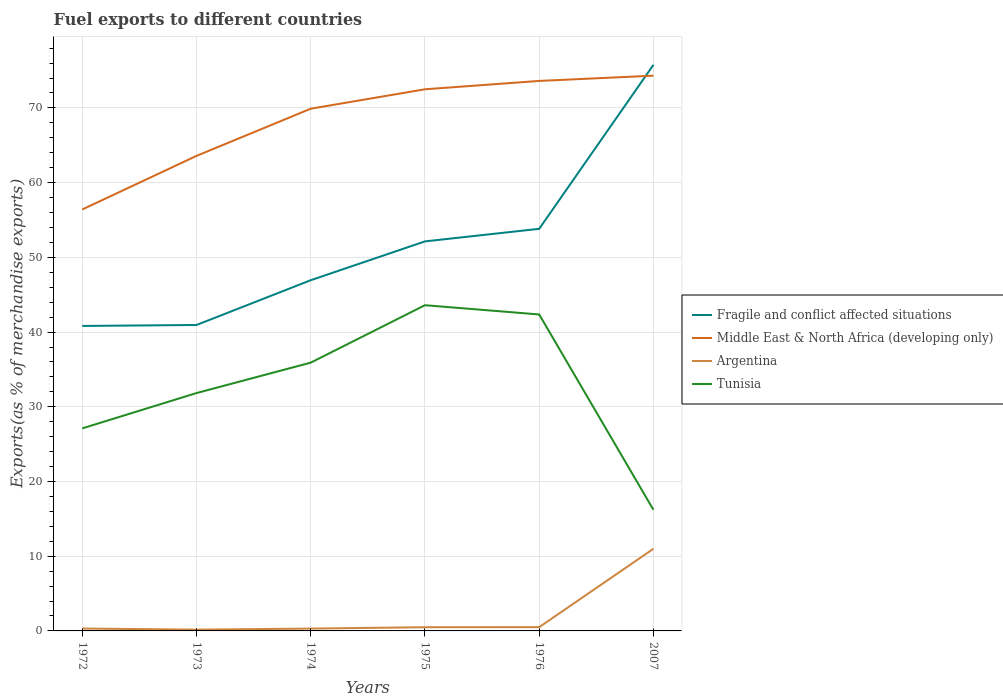How many different coloured lines are there?
Your answer should be very brief. 4. Is the number of lines equal to the number of legend labels?
Your answer should be compact. Yes. Across all years, what is the maximum percentage of exports to different countries in Argentina?
Offer a very short reply. 0.17. In which year was the percentage of exports to different countries in Middle East & North Africa (developing only) maximum?
Offer a terse response. 1972. What is the total percentage of exports to different countries in Fragile and conflict affected situations in the graph?
Provide a short and direct response. -11.19. What is the difference between the highest and the second highest percentage of exports to different countries in Fragile and conflict affected situations?
Your answer should be compact. 34.95. What is the difference between the highest and the lowest percentage of exports to different countries in Middle East & North Africa (developing only)?
Offer a terse response. 4. Is the percentage of exports to different countries in Tunisia strictly greater than the percentage of exports to different countries in Middle East & North Africa (developing only) over the years?
Provide a succinct answer. Yes. How many years are there in the graph?
Provide a succinct answer. 6. Are the values on the major ticks of Y-axis written in scientific E-notation?
Offer a terse response. No. Where does the legend appear in the graph?
Provide a short and direct response. Center right. How are the legend labels stacked?
Your answer should be very brief. Vertical. What is the title of the graph?
Make the answer very short. Fuel exports to different countries. What is the label or title of the X-axis?
Provide a succinct answer. Years. What is the label or title of the Y-axis?
Give a very brief answer. Exports(as % of merchandise exports). What is the Exports(as % of merchandise exports) in Fragile and conflict affected situations in 1972?
Make the answer very short. 40.82. What is the Exports(as % of merchandise exports) in Middle East & North Africa (developing only) in 1972?
Offer a terse response. 56.41. What is the Exports(as % of merchandise exports) of Argentina in 1972?
Provide a short and direct response. 0.32. What is the Exports(as % of merchandise exports) of Tunisia in 1972?
Your answer should be very brief. 27.11. What is the Exports(as % of merchandise exports) of Fragile and conflict affected situations in 1973?
Give a very brief answer. 40.95. What is the Exports(as % of merchandise exports) in Middle East & North Africa (developing only) in 1973?
Provide a succinct answer. 63.58. What is the Exports(as % of merchandise exports) in Argentina in 1973?
Your answer should be very brief. 0.17. What is the Exports(as % of merchandise exports) in Tunisia in 1973?
Your response must be concise. 31.84. What is the Exports(as % of merchandise exports) of Fragile and conflict affected situations in 1974?
Provide a short and direct response. 46.94. What is the Exports(as % of merchandise exports) in Middle East & North Africa (developing only) in 1974?
Keep it short and to the point. 69.9. What is the Exports(as % of merchandise exports) of Argentina in 1974?
Your answer should be very brief. 0.31. What is the Exports(as % of merchandise exports) of Tunisia in 1974?
Provide a succinct answer. 35.91. What is the Exports(as % of merchandise exports) in Fragile and conflict affected situations in 1975?
Provide a succinct answer. 52.14. What is the Exports(as % of merchandise exports) in Middle East & North Africa (developing only) in 1975?
Your answer should be compact. 72.5. What is the Exports(as % of merchandise exports) of Argentina in 1975?
Your response must be concise. 0.49. What is the Exports(as % of merchandise exports) of Tunisia in 1975?
Your answer should be compact. 43.6. What is the Exports(as % of merchandise exports) of Fragile and conflict affected situations in 1976?
Give a very brief answer. 53.82. What is the Exports(as % of merchandise exports) of Middle East & North Africa (developing only) in 1976?
Your answer should be very brief. 73.62. What is the Exports(as % of merchandise exports) in Argentina in 1976?
Ensure brevity in your answer.  0.5. What is the Exports(as % of merchandise exports) of Tunisia in 1976?
Your response must be concise. 42.36. What is the Exports(as % of merchandise exports) in Fragile and conflict affected situations in 2007?
Provide a succinct answer. 75.77. What is the Exports(as % of merchandise exports) in Middle East & North Africa (developing only) in 2007?
Offer a very short reply. 74.32. What is the Exports(as % of merchandise exports) in Argentina in 2007?
Your answer should be very brief. 10.99. What is the Exports(as % of merchandise exports) of Tunisia in 2007?
Offer a terse response. 16.21. Across all years, what is the maximum Exports(as % of merchandise exports) of Fragile and conflict affected situations?
Provide a succinct answer. 75.77. Across all years, what is the maximum Exports(as % of merchandise exports) in Middle East & North Africa (developing only)?
Offer a very short reply. 74.32. Across all years, what is the maximum Exports(as % of merchandise exports) in Argentina?
Keep it short and to the point. 10.99. Across all years, what is the maximum Exports(as % of merchandise exports) of Tunisia?
Make the answer very short. 43.6. Across all years, what is the minimum Exports(as % of merchandise exports) of Fragile and conflict affected situations?
Ensure brevity in your answer.  40.82. Across all years, what is the minimum Exports(as % of merchandise exports) of Middle East & North Africa (developing only)?
Keep it short and to the point. 56.41. Across all years, what is the minimum Exports(as % of merchandise exports) in Argentina?
Ensure brevity in your answer.  0.17. Across all years, what is the minimum Exports(as % of merchandise exports) in Tunisia?
Provide a succinct answer. 16.21. What is the total Exports(as % of merchandise exports) of Fragile and conflict affected situations in the graph?
Offer a very short reply. 310.43. What is the total Exports(as % of merchandise exports) in Middle East & North Africa (developing only) in the graph?
Give a very brief answer. 410.31. What is the total Exports(as % of merchandise exports) of Argentina in the graph?
Make the answer very short. 12.8. What is the total Exports(as % of merchandise exports) of Tunisia in the graph?
Give a very brief answer. 197.01. What is the difference between the Exports(as % of merchandise exports) of Fragile and conflict affected situations in 1972 and that in 1973?
Provide a succinct answer. -0.13. What is the difference between the Exports(as % of merchandise exports) of Middle East & North Africa (developing only) in 1972 and that in 1973?
Offer a very short reply. -7.17. What is the difference between the Exports(as % of merchandise exports) of Argentina in 1972 and that in 1973?
Your response must be concise. 0.15. What is the difference between the Exports(as % of merchandise exports) in Tunisia in 1972 and that in 1973?
Your answer should be very brief. -4.73. What is the difference between the Exports(as % of merchandise exports) in Fragile and conflict affected situations in 1972 and that in 1974?
Ensure brevity in your answer.  -6.12. What is the difference between the Exports(as % of merchandise exports) in Middle East & North Africa (developing only) in 1972 and that in 1974?
Provide a short and direct response. -13.49. What is the difference between the Exports(as % of merchandise exports) in Argentina in 1972 and that in 1974?
Offer a terse response. 0.01. What is the difference between the Exports(as % of merchandise exports) of Tunisia in 1972 and that in 1974?
Keep it short and to the point. -8.8. What is the difference between the Exports(as % of merchandise exports) of Fragile and conflict affected situations in 1972 and that in 1975?
Make the answer very short. -11.32. What is the difference between the Exports(as % of merchandise exports) of Middle East & North Africa (developing only) in 1972 and that in 1975?
Make the answer very short. -16.09. What is the difference between the Exports(as % of merchandise exports) in Argentina in 1972 and that in 1975?
Make the answer very short. -0.17. What is the difference between the Exports(as % of merchandise exports) in Tunisia in 1972 and that in 1975?
Your answer should be compact. -16.49. What is the difference between the Exports(as % of merchandise exports) in Fragile and conflict affected situations in 1972 and that in 1976?
Offer a very short reply. -13. What is the difference between the Exports(as % of merchandise exports) in Middle East & North Africa (developing only) in 1972 and that in 1976?
Your answer should be very brief. -17.21. What is the difference between the Exports(as % of merchandise exports) of Argentina in 1972 and that in 1976?
Offer a terse response. -0.18. What is the difference between the Exports(as % of merchandise exports) in Tunisia in 1972 and that in 1976?
Provide a succinct answer. -15.25. What is the difference between the Exports(as % of merchandise exports) of Fragile and conflict affected situations in 1972 and that in 2007?
Provide a short and direct response. -34.95. What is the difference between the Exports(as % of merchandise exports) of Middle East & North Africa (developing only) in 1972 and that in 2007?
Ensure brevity in your answer.  -17.91. What is the difference between the Exports(as % of merchandise exports) of Argentina in 1972 and that in 2007?
Offer a very short reply. -10.67. What is the difference between the Exports(as % of merchandise exports) in Tunisia in 1972 and that in 2007?
Provide a short and direct response. 10.9. What is the difference between the Exports(as % of merchandise exports) of Fragile and conflict affected situations in 1973 and that in 1974?
Your response must be concise. -5.99. What is the difference between the Exports(as % of merchandise exports) in Middle East & North Africa (developing only) in 1973 and that in 1974?
Offer a terse response. -6.31. What is the difference between the Exports(as % of merchandise exports) in Argentina in 1973 and that in 1974?
Offer a terse response. -0.14. What is the difference between the Exports(as % of merchandise exports) of Tunisia in 1973 and that in 1974?
Give a very brief answer. -4.07. What is the difference between the Exports(as % of merchandise exports) in Fragile and conflict affected situations in 1973 and that in 1975?
Your answer should be very brief. -11.19. What is the difference between the Exports(as % of merchandise exports) of Middle East & North Africa (developing only) in 1973 and that in 1975?
Your answer should be very brief. -8.91. What is the difference between the Exports(as % of merchandise exports) of Argentina in 1973 and that in 1975?
Make the answer very short. -0.32. What is the difference between the Exports(as % of merchandise exports) in Tunisia in 1973 and that in 1975?
Your response must be concise. -11.76. What is the difference between the Exports(as % of merchandise exports) in Fragile and conflict affected situations in 1973 and that in 1976?
Your response must be concise. -12.87. What is the difference between the Exports(as % of merchandise exports) of Middle East & North Africa (developing only) in 1973 and that in 1976?
Ensure brevity in your answer.  -10.03. What is the difference between the Exports(as % of merchandise exports) in Argentina in 1973 and that in 1976?
Ensure brevity in your answer.  -0.33. What is the difference between the Exports(as % of merchandise exports) of Tunisia in 1973 and that in 1976?
Provide a succinct answer. -10.52. What is the difference between the Exports(as % of merchandise exports) in Fragile and conflict affected situations in 1973 and that in 2007?
Your response must be concise. -34.82. What is the difference between the Exports(as % of merchandise exports) of Middle East & North Africa (developing only) in 1973 and that in 2007?
Provide a succinct answer. -10.74. What is the difference between the Exports(as % of merchandise exports) of Argentina in 1973 and that in 2007?
Make the answer very short. -10.82. What is the difference between the Exports(as % of merchandise exports) of Tunisia in 1973 and that in 2007?
Offer a very short reply. 15.63. What is the difference between the Exports(as % of merchandise exports) in Fragile and conflict affected situations in 1974 and that in 1975?
Your answer should be compact. -5.2. What is the difference between the Exports(as % of merchandise exports) of Middle East & North Africa (developing only) in 1974 and that in 1975?
Offer a very short reply. -2.6. What is the difference between the Exports(as % of merchandise exports) in Argentina in 1974 and that in 1975?
Provide a short and direct response. -0.18. What is the difference between the Exports(as % of merchandise exports) in Tunisia in 1974 and that in 1975?
Your response must be concise. -7.69. What is the difference between the Exports(as % of merchandise exports) in Fragile and conflict affected situations in 1974 and that in 1976?
Make the answer very short. -6.88. What is the difference between the Exports(as % of merchandise exports) of Middle East & North Africa (developing only) in 1974 and that in 1976?
Keep it short and to the point. -3.72. What is the difference between the Exports(as % of merchandise exports) in Argentina in 1974 and that in 1976?
Ensure brevity in your answer.  -0.19. What is the difference between the Exports(as % of merchandise exports) in Tunisia in 1974 and that in 1976?
Your response must be concise. -6.45. What is the difference between the Exports(as % of merchandise exports) in Fragile and conflict affected situations in 1974 and that in 2007?
Provide a succinct answer. -28.83. What is the difference between the Exports(as % of merchandise exports) of Middle East & North Africa (developing only) in 1974 and that in 2007?
Provide a short and direct response. -4.42. What is the difference between the Exports(as % of merchandise exports) in Argentina in 1974 and that in 2007?
Keep it short and to the point. -10.68. What is the difference between the Exports(as % of merchandise exports) in Tunisia in 1974 and that in 2007?
Keep it short and to the point. 19.7. What is the difference between the Exports(as % of merchandise exports) in Fragile and conflict affected situations in 1975 and that in 1976?
Your answer should be very brief. -1.68. What is the difference between the Exports(as % of merchandise exports) in Middle East & North Africa (developing only) in 1975 and that in 1976?
Your answer should be compact. -1.12. What is the difference between the Exports(as % of merchandise exports) in Argentina in 1975 and that in 1976?
Give a very brief answer. -0.01. What is the difference between the Exports(as % of merchandise exports) in Tunisia in 1975 and that in 1976?
Your answer should be very brief. 1.24. What is the difference between the Exports(as % of merchandise exports) of Fragile and conflict affected situations in 1975 and that in 2007?
Make the answer very short. -23.63. What is the difference between the Exports(as % of merchandise exports) of Middle East & North Africa (developing only) in 1975 and that in 2007?
Ensure brevity in your answer.  -1.82. What is the difference between the Exports(as % of merchandise exports) of Argentina in 1975 and that in 2007?
Ensure brevity in your answer.  -10.5. What is the difference between the Exports(as % of merchandise exports) in Tunisia in 1975 and that in 2007?
Keep it short and to the point. 27.39. What is the difference between the Exports(as % of merchandise exports) in Fragile and conflict affected situations in 1976 and that in 2007?
Your answer should be very brief. -21.95. What is the difference between the Exports(as % of merchandise exports) of Middle East & North Africa (developing only) in 1976 and that in 2007?
Your answer should be very brief. -0.7. What is the difference between the Exports(as % of merchandise exports) in Argentina in 1976 and that in 2007?
Ensure brevity in your answer.  -10.49. What is the difference between the Exports(as % of merchandise exports) in Tunisia in 1976 and that in 2007?
Your response must be concise. 26.15. What is the difference between the Exports(as % of merchandise exports) in Fragile and conflict affected situations in 1972 and the Exports(as % of merchandise exports) in Middle East & North Africa (developing only) in 1973?
Ensure brevity in your answer.  -22.76. What is the difference between the Exports(as % of merchandise exports) in Fragile and conflict affected situations in 1972 and the Exports(as % of merchandise exports) in Argentina in 1973?
Provide a succinct answer. 40.65. What is the difference between the Exports(as % of merchandise exports) in Fragile and conflict affected situations in 1972 and the Exports(as % of merchandise exports) in Tunisia in 1973?
Offer a terse response. 8.98. What is the difference between the Exports(as % of merchandise exports) of Middle East & North Africa (developing only) in 1972 and the Exports(as % of merchandise exports) of Argentina in 1973?
Provide a short and direct response. 56.24. What is the difference between the Exports(as % of merchandise exports) of Middle East & North Africa (developing only) in 1972 and the Exports(as % of merchandise exports) of Tunisia in 1973?
Your answer should be very brief. 24.57. What is the difference between the Exports(as % of merchandise exports) in Argentina in 1972 and the Exports(as % of merchandise exports) in Tunisia in 1973?
Your response must be concise. -31.51. What is the difference between the Exports(as % of merchandise exports) of Fragile and conflict affected situations in 1972 and the Exports(as % of merchandise exports) of Middle East & North Africa (developing only) in 1974?
Provide a succinct answer. -29.08. What is the difference between the Exports(as % of merchandise exports) in Fragile and conflict affected situations in 1972 and the Exports(as % of merchandise exports) in Argentina in 1974?
Offer a very short reply. 40.51. What is the difference between the Exports(as % of merchandise exports) in Fragile and conflict affected situations in 1972 and the Exports(as % of merchandise exports) in Tunisia in 1974?
Provide a succinct answer. 4.91. What is the difference between the Exports(as % of merchandise exports) in Middle East & North Africa (developing only) in 1972 and the Exports(as % of merchandise exports) in Argentina in 1974?
Provide a short and direct response. 56.09. What is the difference between the Exports(as % of merchandise exports) in Middle East & North Africa (developing only) in 1972 and the Exports(as % of merchandise exports) in Tunisia in 1974?
Your answer should be very brief. 20.5. What is the difference between the Exports(as % of merchandise exports) of Argentina in 1972 and the Exports(as % of merchandise exports) of Tunisia in 1974?
Provide a succinct answer. -35.59. What is the difference between the Exports(as % of merchandise exports) in Fragile and conflict affected situations in 1972 and the Exports(as % of merchandise exports) in Middle East & North Africa (developing only) in 1975?
Offer a terse response. -31.68. What is the difference between the Exports(as % of merchandise exports) of Fragile and conflict affected situations in 1972 and the Exports(as % of merchandise exports) of Argentina in 1975?
Offer a very short reply. 40.33. What is the difference between the Exports(as % of merchandise exports) in Fragile and conflict affected situations in 1972 and the Exports(as % of merchandise exports) in Tunisia in 1975?
Provide a succinct answer. -2.78. What is the difference between the Exports(as % of merchandise exports) of Middle East & North Africa (developing only) in 1972 and the Exports(as % of merchandise exports) of Argentina in 1975?
Provide a succinct answer. 55.91. What is the difference between the Exports(as % of merchandise exports) in Middle East & North Africa (developing only) in 1972 and the Exports(as % of merchandise exports) in Tunisia in 1975?
Offer a terse response. 12.81. What is the difference between the Exports(as % of merchandise exports) of Argentina in 1972 and the Exports(as % of merchandise exports) of Tunisia in 1975?
Provide a short and direct response. -43.27. What is the difference between the Exports(as % of merchandise exports) in Fragile and conflict affected situations in 1972 and the Exports(as % of merchandise exports) in Middle East & North Africa (developing only) in 1976?
Offer a terse response. -32.79. What is the difference between the Exports(as % of merchandise exports) in Fragile and conflict affected situations in 1972 and the Exports(as % of merchandise exports) in Argentina in 1976?
Provide a short and direct response. 40.32. What is the difference between the Exports(as % of merchandise exports) in Fragile and conflict affected situations in 1972 and the Exports(as % of merchandise exports) in Tunisia in 1976?
Offer a very short reply. -1.53. What is the difference between the Exports(as % of merchandise exports) of Middle East & North Africa (developing only) in 1972 and the Exports(as % of merchandise exports) of Argentina in 1976?
Your response must be concise. 55.91. What is the difference between the Exports(as % of merchandise exports) in Middle East & North Africa (developing only) in 1972 and the Exports(as % of merchandise exports) in Tunisia in 1976?
Offer a terse response. 14.05. What is the difference between the Exports(as % of merchandise exports) in Argentina in 1972 and the Exports(as % of merchandise exports) in Tunisia in 1976?
Offer a very short reply. -42.03. What is the difference between the Exports(as % of merchandise exports) in Fragile and conflict affected situations in 1972 and the Exports(as % of merchandise exports) in Middle East & North Africa (developing only) in 2007?
Make the answer very short. -33.5. What is the difference between the Exports(as % of merchandise exports) of Fragile and conflict affected situations in 1972 and the Exports(as % of merchandise exports) of Argentina in 2007?
Make the answer very short. 29.83. What is the difference between the Exports(as % of merchandise exports) in Fragile and conflict affected situations in 1972 and the Exports(as % of merchandise exports) in Tunisia in 2007?
Offer a very short reply. 24.61. What is the difference between the Exports(as % of merchandise exports) of Middle East & North Africa (developing only) in 1972 and the Exports(as % of merchandise exports) of Argentina in 2007?
Ensure brevity in your answer.  45.41. What is the difference between the Exports(as % of merchandise exports) in Middle East & North Africa (developing only) in 1972 and the Exports(as % of merchandise exports) in Tunisia in 2007?
Ensure brevity in your answer.  40.2. What is the difference between the Exports(as % of merchandise exports) in Argentina in 1972 and the Exports(as % of merchandise exports) in Tunisia in 2007?
Give a very brief answer. -15.89. What is the difference between the Exports(as % of merchandise exports) of Fragile and conflict affected situations in 1973 and the Exports(as % of merchandise exports) of Middle East & North Africa (developing only) in 1974?
Keep it short and to the point. -28.95. What is the difference between the Exports(as % of merchandise exports) of Fragile and conflict affected situations in 1973 and the Exports(as % of merchandise exports) of Argentina in 1974?
Make the answer very short. 40.63. What is the difference between the Exports(as % of merchandise exports) in Fragile and conflict affected situations in 1973 and the Exports(as % of merchandise exports) in Tunisia in 1974?
Ensure brevity in your answer.  5.04. What is the difference between the Exports(as % of merchandise exports) of Middle East & North Africa (developing only) in 1973 and the Exports(as % of merchandise exports) of Argentina in 1974?
Ensure brevity in your answer.  63.27. What is the difference between the Exports(as % of merchandise exports) of Middle East & North Africa (developing only) in 1973 and the Exports(as % of merchandise exports) of Tunisia in 1974?
Ensure brevity in your answer.  27.67. What is the difference between the Exports(as % of merchandise exports) in Argentina in 1973 and the Exports(as % of merchandise exports) in Tunisia in 1974?
Make the answer very short. -35.74. What is the difference between the Exports(as % of merchandise exports) in Fragile and conflict affected situations in 1973 and the Exports(as % of merchandise exports) in Middle East & North Africa (developing only) in 1975?
Offer a very short reply. -31.55. What is the difference between the Exports(as % of merchandise exports) of Fragile and conflict affected situations in 1973 and the Exports(as % of merchandise exports) of Argentina in 1975?
Offer a very short reply. 40.45. What is the difference between the Exports(as % of merchandise exports) in Fragile and conflict affected situations in 1973 and the Exports(as % of merchandise exports) in Tunisia in 1975?
Provide a short and direct response. -2.65. What is the difference between the Exports(as % of merchandise exports) of Middle East & North Africa (developing only) in 1973 and the Exports(as % of merchandise exports) of Argentina in 1975?
Your answer should be compact. 63.09. What is the difference between the Exports(as % of merchandise exports) in Middle East & North Africa (developing only) in 1973 and the Exports(as % of merchandise exports) in Tunisia in 1975?
Offer a terse response. 19.98. What is the difference between the Exports(as % of merchandise exports) of Argentina in 1973 and the Exports(as % of merchandise exports) of Tunisia in 1975?
Your answer should be compact. -43.42. What is the difference between the Exports(as % of merchandise exports) of Fragile and conflict affected situations in 1973 and the Exports(as % of merchandise exports) of Middle East & North Africa (developing only) in 1976?
Give a very brief answer. -32.67. What is the difference between the Exports(as % of merchandise exports) in Fragile and conflict affected situations in 1973 and the Exports(as % of merchandise exports) in Argentina in 1976?
Give a very brief answer. 40.44. What is the difference between the Exports(as % of merchandise exports) in Fragile and conflict affected situations in 1973 and the Exports(as % of merchandise exports) in Tunisia in 1976?
Offer a very short reply. -1.41. What is the difference between the Exports(as % of merchandise exports) in Middle East & North Africa (developing only) in 1973 and the Exports(as % of merchandise exports) in Argentina in 1976?
Make the answer very short. 63.08. What is the difference between the Exports(as % of merchandise exports) of Middle East & North Africa (developing only) in 1973 and the Exports(as % of merchandise exports) of Tunisia in 1976?
Your answer should be compact. 21.23. What is the difference between the Exports(as % of merchandise exports) of Argentina in 1973 and the Exports(as % of merchandise exports) of Tunisia in 1976?
Your response must be concise. -42.18. What is the difference between the Exports(as % of merchandise exports) in Fragile and conflict affected situations in 1973 and the Exports(as % of merchandise exports) in Middle East & North Africa (developing only) in 2007?
Give a very brief answer. -33.37. What is the difference between the Exports(as % of merchandise exports) in Fragile and conflict affected situations in 1973 and the Exports(as % of merchandise exports) in Argentina in 2007?
Your response must be concise. 29.95. What is the difference between the Exports(as % of merchandise exports) in Fragile and conflict affected situations in 1973 and the Exports(as % of merchandise exports) in Tunisia in 2007?
Your response must be concise. 24.74. What is the difference between the Exports(as % of merchandise exports) of Middle East & North Africa (developing only) in 1973 and the Exports(as % of merchandise exports) of Argentina in 2007?
Make the answer very short. 52.59. What is the difference between the Exports(as % of merchandise exports) in Middle East & North Africa (developing only) in 1973 and the Exports(as % of merchandise exports) in Tunisia in 2007?
Provide a succinct answer. 47.37. What is the difference between the Exports(as % of merchandise exports) of Argentina in 1973 and the Exports(as % of merchandise exports) of Tunisia in 2007?
Offer a terse response. -16.04. What is the difference between the Exports(as % of merchandise exports) in Fragile and conflict affected situations in 1974 and the Exports(as % of merchandise exports) in Middle East & North Africa (developing only) in 1975?
Offer a terse response. -25.56. What is the difference between the Exports(as % of merchandise exports) in Fragile and conflict affected situations in 1974 and the Exports(as % of merchandise exports) in Argentina in 1975?
Give a very brief answer. 46.45. What is the difference between the Exports(as % of merchandise exports) of Fragile and conflict affected situations in 1974 and the Exports(as % of merchandise exports) of Tunisia in 1975?
Your response must be concise. 3.34. What is the difference between the Exports(as % of merchandise exports) in Middle East & North Africa (developing only) in 1974 and the Exports(as % of merchandise exports) in Argentina in 1975?
Your response must be concise. 69.4. What is the difference between the Exports(as % of merchandise exports) of Middle East & North Africa (developing only) in 1974 and the Exports(as % of merchandise exports) of Tunisia in 1975?
Provide a short and direct response. 26.3. What is the difference between the Exports(as % of merchandise exports) in Argentina in 1974 and the Exports(as % of merchandise exports) in Tunisia in 1975?
Provide a succinct answer. -43.28. What is the difference between the Exports(as % of merchandise exports) of Fragile and conflict affected situations in 1974 and the Exports(as % of merchandise exports) of Middle East & North Africa (developing only) in 1976?
Provide a succinct answer. -26.68. What is the difference between the Exports(as % of merchandise exports) of Fragile and conflict affected situations in 1974 and the Exports(as % of merchandise exports) of Argentina in 1976?
Give a very brief answer. 46.44. What is the difference between the Exports(as % of merchandise exports) of Fragile and conflict affected situations in 1974 and the Exports(as % of merchandise exports) of Tunisia in 1976?
Keep it short and to the point. 4.58. What is the difference between the Exports(as % of merchandise exports) of Middle East & North Africa (developing only) in 1974 and the Exports(as % of merchandise exports) of Argentina in 1976?
Provide a short and direct response. 69.39. What is the difference between the Exports(as % of merchandise exports) in Middle East & North Africa (developing only) in 1974 and the Exports(as % of merchandise exports) in Tunisia in 1976?
Ensure brevity in your answer.  27.54. What is the difference between the Exports(as % of merchandise exports) of Argentina in 1974 and the Exports(as % of merchandise exports) of Tunisia in 1976?
Provide a short and direct response. -42.04. What is the difference between the Exports(as % of merchandise exports) in Fragile and conflict affected situations in 1974 and the Exports(as % of merchandise exports) in Middle East & North Africa (developing only) in 2007?
Provide a short and direct response. -27.38. What is the difference between the Exports(as % of merchandise exports) in Fragile and conflict affected situations in 1974 and the Exports(as % of merchandise exports) in Argentina in 2007?
Offer a terse response. 35.95. What is the difference between the Exports(as % of merchandise exports) of Fragile and conflict affected situations in 1974 and the Exports(as % of merchandise exports) of Tunisia in 2007?
Provide a succinct answer. 30.73. What is the difference between the Exports(as % of merchandise exports) of Middle East & North Africa (developing only) in 1974 and the Exports(as % of merchandise exports) of Argentina in 2007?
Give a very brief answer. 58.9. What is the difference between the Exports(as % of merchandise exports) of Middle East & North Africa (developing only) in 1974 and the Exports(as % of merchandise exports) of Tunisia in 2007?
Your response must be concise. 53.69. What is the difference between the Exports(as % of merchandise exports) of Argentina in 1974 and the Exports(as % of merchandise exports) of Tunisia in 2007?
Offer a terse response. -15.89. What is the difference between the Exports(as % of merchandise exports) in Fragile and conflict affected situations in 1975 and the Exports(as % of merchandise exports) in Middle East & North Africa (developing only) in 1976?
Ensure brevity in your answer.  -21.48. What is the difference between the Exports(as % of merchandise exports) in Fragile and conflict affected situations in 1975 and the Exports(as % of merchandise exports) in Argentina in 1976?
Make the answer very short. 51.63. What is the difference between the Exports(as % of merchandise exports) in Fragile and conflict affected situations in 1975 and the Exports(as % of merchandise exports) in Tunisia in 1976?
Your response must be concise. 9.78. What is the difference between the Exports(as % of merchandise exports) of Middle East & North Africa (developing only) in 1975 and the Exports(as % of merchandise exports) of Argentina in 1976?
Your response must be concise. 71.99. What is the difference between the Exports(as % of merchandise exports) in Middle East & North Africa (developing only) in 1975 and the Exports(as % of merchandise exports) in Tunisia in 1976?
Make the answer very short. 30.14. What is the difference between the Exports(as % of merchandise exports) of Argentina in 1975 and the Exports(as % of merchandise exports) of Tunisia in 1976?
Provide a succinct answer. -41.86. What is the difference between the Exports(as % of merchandise exports) in Fragile and conflict affected situations in 1975 and the Exports(as % of merchandise exports) in Middle East & North Africa (developing only) in 2007?
Your answer should be compact. -22.18. What is the difference between the Exports(as % of merchandise exports) of Fragile and conflict affected situations in 1975 and the Exports(as % of merchandise exports) of Argentina in 2007?
Your answer should be very brief. 41.14. What is the difference between the Exports(as % of merchandise exports) in Fragile and conflict affected situations in 1975 and the Exports(as % of merchandise exports) in Tunisia in 2007?
Your response must be concise. 35.93. What is the difference between the Exports(as % of merchandise exports) of Middle East & North Africa (developing only) in 1975 and the Exports(as % of merchandise exports) of Argentina in 2007?
Your answer should be very brief. 61.5. What is the difference between the Exports(as % of merchandise exports) of Middle East & North Africa (developing only) in 1975 and the Exports(as % of merchandise exports) of Tunisia in 2007?
Provide a succinct answer. 56.29. What is the difference between the Exports(as % of merchandise exports) in Argentina in 1975 and the Exports(as % of merchandise exports) in Tunisia in 2007?
Offer a very short reply. -15.71. What is the difference between the Exports(as % of merchandise exports) of Fragile and conflict affected situations in 1976 and the Exports(as % of merchandise exports) of Middle East & North Africa (developing only) in 2007?
Keep it short and to the point. -20.5. What is the difference between the Exports(as % of merchandise exports) of Fragile and conflict affected situations in 1976 and the Exports(as % of merchandise exports) of Argentina in 2007?
Provide a short and direct response. 42.83. What is the difference between the Exports(as % of merchandise exports) of Fragile and conflict affected situations in 1976 and the Exports(as % of merchandise exports) of Tunisia in 2007?
Ensure brevity in your answer.  37.61. What is the difference between the Exports(as % of merchandise exports) in Middle East & North Africa (developing only) in 1976 and the Exports(as % of merchandise exports) in Argentina in 2007?
Ensure brevity in your answer.  62.62. What is the difference between the Exports(as % of merchandise exports) in Middle East & North Africa (developing only) in 1976 and the Exports(as % of merchandise exports) in Tunisia in 2007?
Ensure brevity in your answer.  57.41. What is the difference between the Exports(as % of merchandise exports) of Argentina in 1976 and the Exports(as % of merchandise exports) of Tunisia in 2007?
Your answer should be compact. -15.7. What is the average Exports(as % of merchandise exports) in Fragile and conflict affected situations per year?
Provide a succinct answer. 51.74. What is the average Exports(as % of merchandise exports) in Middle East & North Africa (developing only) per year?
Provide a short and direct response. 68.39. What is the average Exports(as % of merchandise exports) of Argentina per year?
Offer a very short reply. 2.13. What is the average Exports(as % of merchandise exports) in Tunisia per year?
Offer a terse response. 32.84. In the year 1972, what is the difference between the Exports(as % of merchandise exports) in Fragile and conflict affected situations and Exports(as % of merchandise exports) in Middle East & North Africa (developing only)?
Keep it short and to the point. -15.59. In the year 1972, what is the difference between the Exports(as % of merchandise exports) in Fragile and conflict affected situations and Exports(as % of merchandise exports) in Argentina?
Make the answer very short. 40.5. In the year 1972, what is the difference between the Exports(as % of merchandise exports) in Fragile and conflict affected situations and Exports(as % of merchandise exports) in Tunisia?
Provide a succinct answer. 13.71. In the year 1972, what is the difference between the Exports(as % of merchandise exports) in Middle East & North Africa (developing only) and Exports(as % of merchandise exports) in Argentina?
Provide a succinct answer. 56.09. In the year 1972, what is the difference between the Exports(as % of merchandise exports) in Middle East & North Africa (developing only) and Exports(as % of merchandise exports) in Tunisia?
Your answer should be compact. 29.3. In the year 1972, what is the difference between the Exports(as % of merchandise exports) of Argentina and Exports(as % of merchandise exports) of Tunisia?
Offer a very short reply. -26.79. In the year 1973, what is the difference between the Exports(as % of merchandise exports) of Fragile and conflict affected situations and Exports(as % of merchandise exports) of Middle East & North Africa (developing only)?
Your answer should be compact. -22.63. In the year 1973, what is the difference between the Exports(as % of merchandise exports) in Fragile and conflict affected situations and Exports(as % of merchandise exports) in Argentina?
Your response must be concise. 40.78. In the year 1973, what is the difference between the Exports(as % of merchandise exports) of Fragile and conflict affected situations and Exports(as % of merchandise exports) of Tunisia?
Provide a short and direct response. 9.11. In the year 1973, what is the difference between the Exports(as % of merchandise exports) of Middle East & North Africa (developing only) and Exports(as % of merchandise exports) of Argentina?
Your answer should be compact. 63.41. In the year 1973, what is the difference between the Exports(as % of merchandise exports) in Middle East & North Africa (developing only) and Exports(as % of merchandise exports) in Tunisia?
Your answer should be compact. 31.75. In the year 1973, what is the difference between the Exports(as % of merchandise exports) of Argentina and Exports(as % of merchandise exports) of Tunisia?
Ensure brevity in your answer.  -31.66. In the year 1974, what is the difference between the Exports(as % of merchandise exports) in Fragile and conflict affected situations and Exports(as % of merchandise exports) in Middle East & North Africa (developing only)?
Your response must be concise. -22.96. In the year 1974, what is the difference between the Exports(as % of merchandise exports) of Fragile and conflict affected situations and Exports(as % of merchandise exports) of Argentina?
Ensure brevity in your answer.  46.63. In the year 1974, what is the difference between the Exports(as % of merchandise exports) in Fragile and conflict affected situations and Exports(as % of merchandise exports) in Tunisia?
Offer a very short reply. 11.03. In the year 1974, what is the difference between the Exports(as % of merchandise exports) of Middle East & North Africa (developing only) and Exports(as % of merchandise exports) of Argentina?
Give a very brief answer. 69.58. In the year 1974, what is the difference between the Exports(as % of merchandise exports) in Middle East & North Africa (developing only) and Exports(as % of merchandise exports) in Tunisia?
Give a very brief answer. 33.99. In the year 1974, what is the difference between the Exports(as % of merchandise exports) of Argentina and Exports(as % of merchandise exports) of Tunisia?
Your answer should be compact. -35.59. In the year 1975, what is the difference between the Exports(as % of merchandise exports) of Fragile and conflict affected situations and Exports(as % of merchandise exports) of Middle East & North Africa (developing only)?
Your answer should be compact. -20.36. In the year 1975, what is the difference between the Exports(as % of merchandise exports) in Fragile and conflict affected situations and Exports(as % of merchandise exports) in Argentina?
Offer a very short reply. 51.64. In the year 1975, what is the difference between the Exports(as % of merchandise exports) in Fragile and conflict affected situations and Exports(as % of merchandise exports) in Tunisia?
Offer a very short reply. 8.54. In the year 1975, what is the difference between the Exports(as % of merchandise exports) of Middle East & North Africa (developing only) and Exports(as % of merchandise exports) of Argentina?
Your answer should be compact. 72. In the year 1975, what is the difference between the Exports(as % of merchandise exports) in Middle East & North Africa (developing only) and Exports(as % of merchandise exports) in Tunisia?
Your answer should be very brief. 28.9. In the year 1975, what is the difference between the Exports(as % of merchandise exports) of Argentina and Exports(as % of merchandise exports) of Tunisia?
Give a very brief answer. -43.1. In the year 1976, what is the difference between the Exports(as % of merchandise exports) of Fragile and conflict affected situations and Exports(as % of merchandise exports) of Middle East & North Africa (developing only)?
Your answer should be very brief. -19.8. In the year 1976, what is the difference between the Exports(as % of merchandise exports) in Fragile and conflict affected situations and Exports(as % of merchandise exports) in Argentina?
Keep it short and to the point. 53.32. In the year 1976, what is the difference between the Exports(as % of merchandise exports) of Fragile and conflict affected situations and Exports(as % of merchandise exports) of Tunisia?
Provide a short and direct response. 11.46. In the year 1976, what is the difference between the Exports(as % of merchandise exports) of Middle East & North Africa (developing only) and Exports(as % of merchandise exports) of Argentina?
Your answer should be compact. 73.11. In the year 1976, what is the difference between the Exports(as % of merchandise exports) of Middle East & North Africa (developing only) and Exports(as % of merchandise exports) of Tunisia?
Your response must be concise. 31.26. In the year 1976, what is the difference between the Exports(as % of merchandise exports) of Argentina and Exports(as % of merchandise exports) of Tunisia?
Provide a succinct answer. -41.85. In the year 2007, what is the difference between the Exports(as % of merchandise exports) of Fragile and conflict affected situations and Exports(as % of merchandise exports) of Middle East & North Africa (developing only)?
Keep it short and to the point. 1.45. In the year 2007, what is the difference between the Exports(as % of merchandise exports) in Fragile and conflict affected situations and Exports(as % of merchandise exports) in Argentina?
Offer a terse response. 64.78. In the year 2007, what is the difference between the Exports(as % of merchandise exports) of Fragile and conflict affected situations and Exports(as % of merchandise exports) of Tunisia?
Provide a short and direct response. 59.56. In the year 2007, what is the difference between the Exports(as % of merchandise exports) in Middle East & North Africa (developing only) and Exports(as % of merchandise exports) in Argentina?
Your response must be concise. 63.32. In the year 2007, what is the difference between the Exports(as % of merchandise exports) in Middle East & North Africa (developing only) and Exports(as % of merchandise exports) in Tunisia?
Ensure brevity in your answer.  58.11. In the year 2007, what is the difference between the Exports(as % of merchandise exports) in Argentina and Exports(as % of merchandise exports) in Tunisia?
Make the answer very short. -5.21. What is the ratio of the Exports(as % of merchandise exports) of Middle East & North Africa (developing only) in 1972 to that in 1973?
Give a very brief answer. 0.89. What is the ratio of the Exports(as % of merchandise exports) of Argentina in 1972 to that in 1973?
Offer a terse response. 1.88. What is the ratio of the Exports(as % of merchandise exports) in Tunisia in 1972 to that in 1973?
Provide a succinct answer. 0.85. What is the ratio of the Exports(as % of merchandise exports) in Fragile and conflict affected situations in 1972 to that in 1974?
Provide a succinct answer. 0.87. What is the ratio of the Exports(as % of merchandise exports) of Middle East & North Africa (developing only) in 1972 to that in 1974?
Your answer should be compact. 0.81. What is the ratio of the Exports(as % of merchandise exports) in Argentina in 1972 to that in 1974?
Offer a terse response. 1.03. What is the ratio of the Exports(as % of merchandise exports) in Tunisia in 1972 to that in 1974?
Offer a very short reply. 0.76. What is the ratio of the Exports(as % of merchandise exports) of Fragile and conflict affected situations in 1972 to that in 1975?
Offer a very short reply. 0.78. What is the ratio of the Exports(as % of merchandise exports) of Middle East & North Africa (developing only) in 1972 to that in 1975?
Your response must be concise. 0.78. What is the ratio of the Exports(as % of merchandise exports) of Argentina in 1972 to that in 1975?
Offer a very short reply. 0.65. What is the ratio of the Exports(as % of merchandise exports) in Tunisia in 1972 to that in 1975?
Keep it short and to the point. 0.62. What is the ratio of the Exports(as % of merchandise exports) of Fragile and conflict affected situations in 1972 to that in 1976?
Your answer should be very brief. 0.76. What is the ratio of the Exports(as % of merchandise exports) in Middle East & North Africa (developing only) in 1972 to that in 1976?
Your answer should be very brief. 0.77. What is the ratio of the Exports(as % of merchandise exports) in Argentina in 1972 to that in 1976?
Offer a terse response. 0.64. What is the ratio of the Exports(as % of merchandise exports) of Tunisia in 1972 to that in 1976?
Keep it short and to the point. 0.64. What is the ratio of the Exports(as % of merchandise exports) in Fragile and conflict affected situations in 1972 to that in 2007?
Your response must be concise. 0.54. What is the ratio of the Exports(as % of merchandise exports) of Middle East & North Africa (developing only) in 1972 to that in 2007?
Your answer should be compact. 0.76. What is the ratio of the Exports(as % of merchandise exports) in Argentina in 1972 to that in 2007?
Your response must be concise. 0.03. What is the ratio of the Exports(as % of merchandise exports) of Tunisia in 1972 to that in 2007?
Offer a very short reply. 1.67. What is the ratio of the Exports(as % of merchandise exports) in Fragile and conflict affected situations in 1973 to that in 1974?
Offer a terse response. 0.87. What is the ratio of the Exports(as % of merchandise exports) in Middle East & North Africa (developing only) in 1973 to that in 1974?
Make the answer very short. 0.91. What is the ratio of the Exports(as % of merchandise exports) in Argentina in 1973 to that in 1974?
Provide a short and direct response. 0.55. What is the ratio of the Exports(as % of merchandise exports) in Tunisia in 1973 to that in 1974?
Make the answer very short. 0.89. What is the ratio of the Exports(as % of merchandise exports) of Fragile and conflict affected situations in 1973 to that in 1975?
Make the answer very short. 0.79. What is the ratio of the Exports(as % of merchandise exports) of Middle East & North Africa (developing only) in 1973 to that in 1975?
Make the answer very short. 0.88. What is the ratio of the Exports(as % of merchandise exports) of Argentina in 1973 to that in 1975?
Offer a terse response. 0.35. What is the ratio of the Exports(as % of merchandise exports) of Tunisia in 1973 to that in 1975?
Give a very brief answer. 0.73. What is the ratio of the Exports(as % of merchandise exports) in Fragile and conflict affected situations in 1973 to that in 1976?
Your answer should be very brief. 0.76. What is the ratio of the Exports(as % of merchandise exports) in Middle East & North Africa (developing only) in 1973 to that in 1976?
Ensure brevity in your answer.  0.86. What is the ratio of the Exports(as % of merchandise exports) of Argentina in 1973 to that in 1976?
Your answer should be compact. 0.34. What is the ratio of the Exports(as % of merchandise exports) in Tunisia in 1973 to that in 1976?
Provide a short and direct response. 0.75. What is the ratio of the Exports(as % of merchandise exports) in Fragile and conflict affected situations in 1973 to that in 2007?
Give a very brief answer. 0.54. What is the ratio of the Exports(as % of merchandise exports) in Middle East & North Africa (developing only) in 1973 to that in 2007?
Your answer should be very brief. 0.86. What is the ratio of the Exports(as % of merchandise exports) in Argentina in 1973 to that in 2007?
Offer a very short reply. 0.02. What is the ratio of the Exports(as % of merchandise exports) of Tunisia in 1973 to that in 2007?
Your answer should be compact. 1.96. What is the ratio of the Exports(as % of merchandise exports) of Fragile and conflict affected situations in 1974 to that in 1975?
Make the answer very short. 0.9. What is the ratio of the Exports(as % of merchandise exports) in Middle East & North Africa (developing only) in 1974 to that in 1975?
Ensure brevity in your answer.  0.96. What is the ratio of the Exports(as % of merchandise exports) of Argentina in 1974 to that in 1975?
Give a very brief answer. 0.63. What is the ratio of the Exports(as % of merchandise exports) in Tunisia in 1974 to that in 1975?
Your answer should be very brief. 0.82. What is the ratio of the Exports(as % of merchandise exports) in Fragile and conflict affected situations in 1974 to that in 1976?
Provide a succinct answer. 0.87. What is the ratio of the Exports(as % of merchandise exports) of Middle East & North Africa (developing only) in 1974 to that in 1976?
Your response must be concise. 0.95. What is the ratio of the Exports(as % of merchandise exports) of Argentina in 1974 to that in 1976?
Offer a terse response. 0.62. What is the ratio of the Exports(as % of merchandise exports) of Tunisia in 1974 to that in 1976?
Provide a succinct answer. 0.85. What is the ratio of the Exports(as % of merchandise exports) in Fragile and conflict affected situations in 1974 to that in 2007?
Provide a succinct answer. 0.62. What is the ratio of the Exports(as % of merchandise exports) of Middle East & North Africa (developing only) in 1974 to that in 2007?
Ensure brevity in your answer.  0.94. What is the ratio of the Exports(as % of merchandise exports) in Argentina in 1974 to that in 2007?
Your answer should be very brief. 0.03. What is the ratio of the Exports(as % of merchandise exports) of Tunisia in 1974 to that in 2007?
Make the answer very short. 2.22. What is the ratio of the Exports(as % of merchandise exports) of Fragile and conflict affected situations in 1975 to that in 1976?
Your answer should be compact. 0.97. What is the ratio of the Exports(as % of merchandise exports) in Middle East & North Africa (developing only) in 1975 to that in 1976?
Your response must be concise. 0.98. What is the ratio of the Exports(as % of merchandise exports) of Argentina in 1975 to that in 1976?
Your answer should be very brief. 0.98. What is the ratio of the Exports(as % of merchandise exports) of Tunisia in 1975 to that in 1976?
Offer a very short reply. 1.03. What is the ratio of the Exports(as % of merchandise exports) in Fragile and conflict affected situations in 1975 to that in 2007?
Offer a very short reply. 0.69. What is the ratio of the Exports(as % of merchandise exports) of Middle East & North Africa (developing only) in 1975 to that in 2007?
Offer a terse response. 0.98. What is the ratio of the Exports(as % of merchandise exports) of Argentina in 1975 to that in 2007?
Provide a short and direct response. 0.04. What is the ratio of the Exports(as % of merchandise exports) in Tunisia in 1975 to that in 2007?
Offer a terse response. 2.69. What is the ratio of the Exports(as % of merchandise exports) of Fragile and conflict affected situations in 1976 to that in 2007?
Make the answer very short. 0.71. What is the ratio of the Exports(as % of merchandise exports) in Argentina in 1976 to that in 2007?
Ensure brevity in your answer.  0.05. What is the ratio of the Exports(as % of merchandise exports) in Tunisia in 1976 to that in 2007?
Make the answer very short. 2.61. What is the difference between the highest and the second highest Exports(as % of merchandise exports) in Fragile and conflict affected situations?
Your answer should be very brief. 21.95. What is the difference between the highest and the second highest Exports(as % of merchandise exports) of Middle East & North Africa (developing only)?
Provide a succinct answer. 0.7. What is the difference between the highest and the second highest Exports(as % of merchandise exports) of Argentina?
Give a very brief answer. 10.49. What is the difference between the highest and the second highest Exports(as % of merchandise exports) of Tunisia?
Provide a short and direct response. 1.24. What is the difference between the highest and the lowest Exports(as % of merchandise exports) of Fragile and conflict affected situations?
Your answer should be very brief. 34.95. What is the difference between the highest and the lowest Exports(as % of merchandise exports) in Middle East & North Africa (developing only)?
Make the answer very short. 17.91. What is the difference between the highest and the lowest Exports(as % of merchandise exports) in Argentina?
Offer a terse response. 10.82. What is the difference between the highest and the lowest Exports(as % of merchandise exports) in Tunisia?
Make the answer very short. 27.39. 